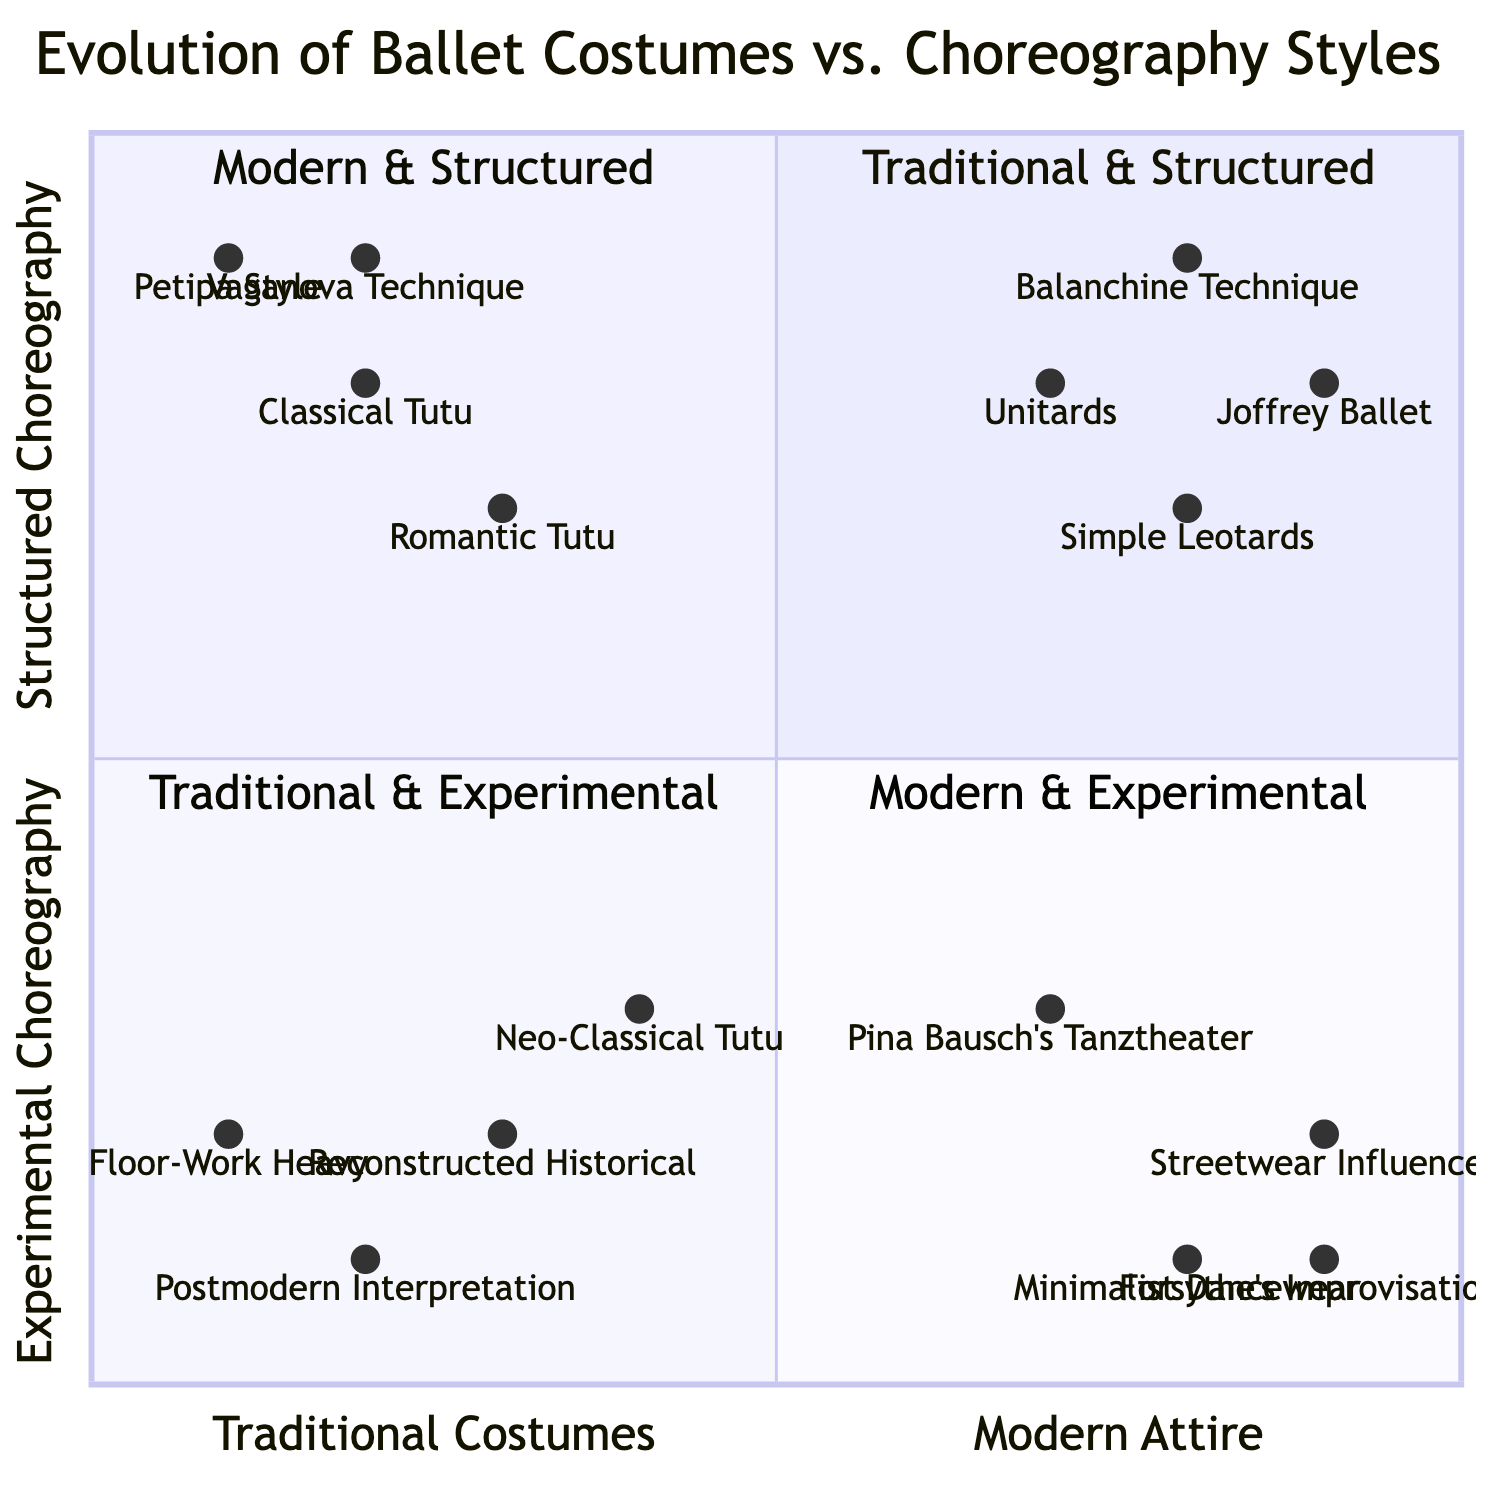What elements are in the Traditional Costumes & Structured Choreography quadrant? To answer this, I look at the top left quadrant labeled "Traditional Costumes & Structured Choreography." The elements listed there include "Classical Tutu (Swan Lake)," "Romantic Tutu (Giselle)," "Petipa Style Choreography (The Sleeping Beauty)," and "Vaganova Technique."
Answer: Classical Tutu (Swan Lake), Romantic Tutu (Giselle), Petipa Style Choreography (The Sleeping Beauty), Vaganova Technique Which quadrant contains Modern Attire with Experimental Choreography? I find the bottom right quadrant, which is labeled "Modern Attire & Experimental Choreography." The elements listed here signify the focus on modern attire combined with an experimental approach to choreography.
Answer: Modern Attire & Experimental Choreography How many elements are in the Traditional Costumes & Experimental Choreography quadrant? I refer to the bottom left quadrant, labeled "Traditional Costumes & Experimental Choreography." The listed elements are "Neo-Classical Tutu (Serenade by George Balanchine)," "Reconstructed Historical Attire (Les Noces by Bronislava Nijinska)," "Postmodern Interpretation (Sewing Machines in Ballet by Jirí Kylián)," and "Floor-Work Heavy Routines (Mark Morris)," making a total of four elements.
Answer: 4 Which choreography style is represented in the Modern Attire & Structured Choreography quadrant? In the top right quadrant, labeled "Modern Attire & Structured Choreography," the elements are "Unitards (Contemporary Ballet)," "Simple Leotards," "Joffrey Ballet Repertoire," and "Balanchine Technique." Therefore, the choreography style represented here is structured.
Answer: Structured Which element from the quadrant chart showcases Experimental Choreography combined with Traditional Costumes? I look into the bottom left quadrant labeled "Traditional Costumes & Experimental Choreography." Among the elements, "Postmodern Interpretation (Sewing Machines in Ballet by Jirí Kylián)" represents a blend of experimental choreography with traditional costumes.
Answer: Postmodern Interpretation (Sewing Machines in Ballet by Jirí Kylián) 